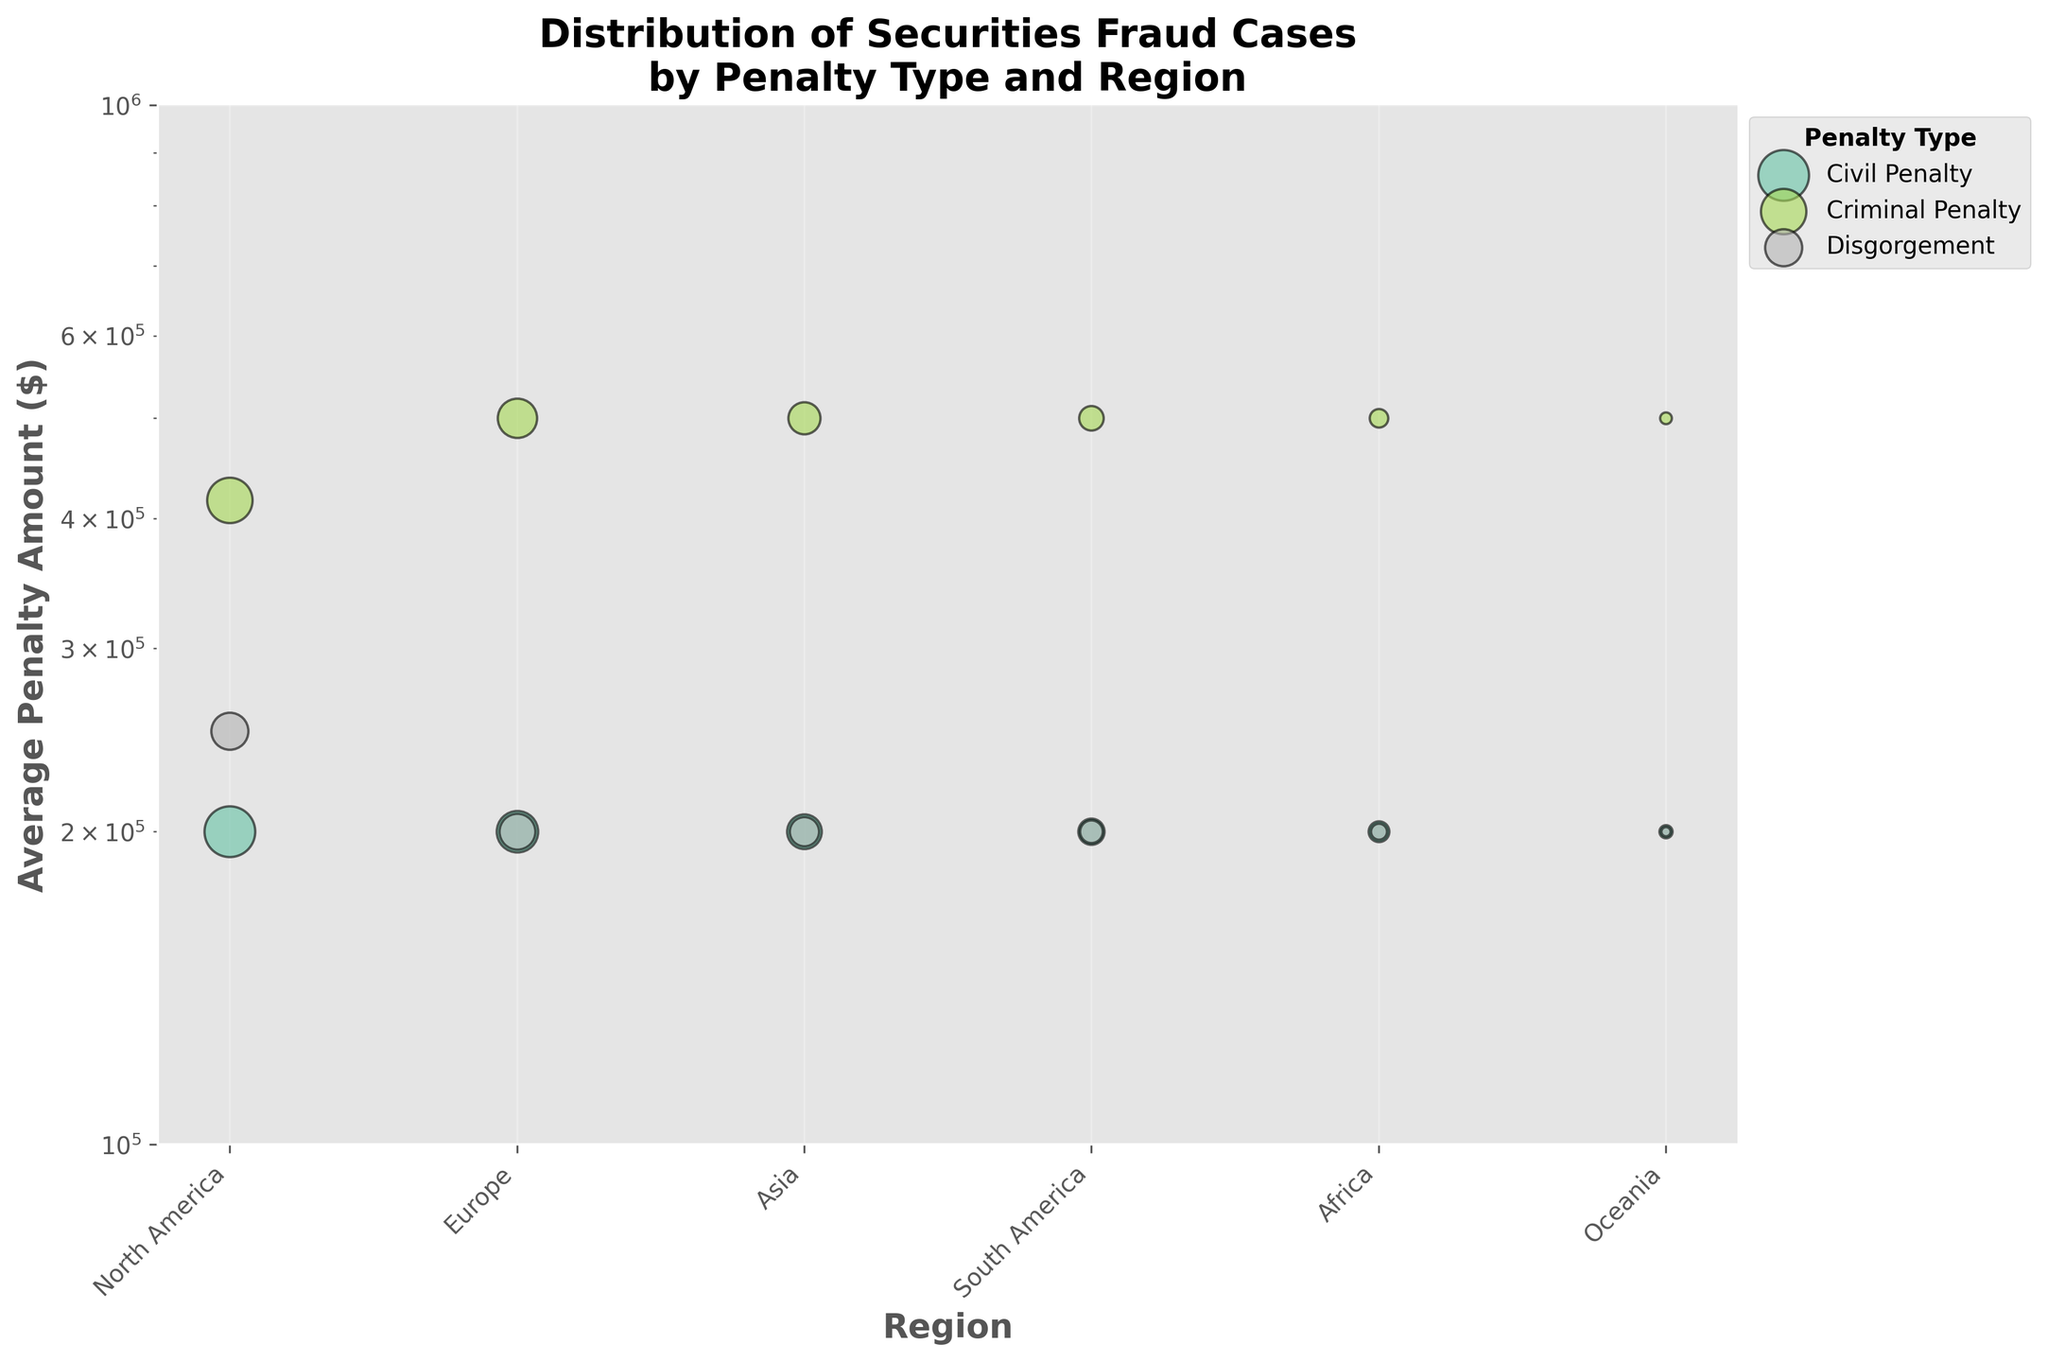What is the title of the plot? The plot title is often found at the top and is a descriptor of what the chart is about. Here, the title is "Distribution of Securities Fraud Cases by Penalty Type and Region," which summarizes what the viewer will observe.
Answer: Distribution of Securities Fraud Cases by Penalty Type and Region Which region has the smallest number of cases for Criminal Penalty? To determine this, look for the smallest bubble representing the number of Criminal Penalty cases in each region. The bubble with the smallest size under the "Criminal Penalty" label belongs to Oceania.
Answer: Oceania What is the average penalty amount for Civil Penalties in Europe? The average penalty amount can be seen on the y-axis where the bubbles representing "Civil Penalty" are plotted. For Europe, the "Civil Penalty" bubble's y-coordinate is 200,000.
Answer: 200,000 How many regions have more than 50 Criminal Penalty cases? Count the regions whose bubbles have a larger size than the one representing 50 cases. North America, Europe, Asia, and South America all have more than 50 Criminal Penalty cases.
Answer: 4 Which penalty type has the highest average penalty amount in all regions combined? Compare the highest y-values among each penalty type across different regions. Criminal Penalty has the highest y-values set at 500,000 in most regions.
Answer: Criminal Penalty Which region has the most diverse types of penalties shown in the plot? Check which region has the most different bubble types (colors) present. North America has bubbles for Civil Penalty, Criminal Penalty, and Disgorgement, showing diversity in penalties.
Answer: North America What is the total number of securities fraud cases in Asia? Sum the number of cases for each penalty type under the "Asia" region: 70 (Civil) + 60 (Criminal) + 50 (Disgorgement). The total is 180 cases in Asia.
Answer: 180 Which penalty type in Africa has the lowest Average Penalty Amount and what is it? For Africa, inspect the y-values for each penalty type bubble. All penalty types (Civil, Criminal, Disgorgement) appear to have the same y-coordinate at 200,000. So they are tied.
Answer: All tied at 200,000 Compare the number of Criminal Penalty cases between North America and Europe. Which one is higher and by how much? Observe the size of bubbles representing Criminal Penalty for both regions. North America has 120 cases, while Europe has 90 cases. The difference is 120 - 90 = 30 cases.
Answer: North America by 30 cases 